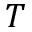Convert formula to latex. <formula><loc_0><loc_0><loc_500><loc_500>T</formula> 